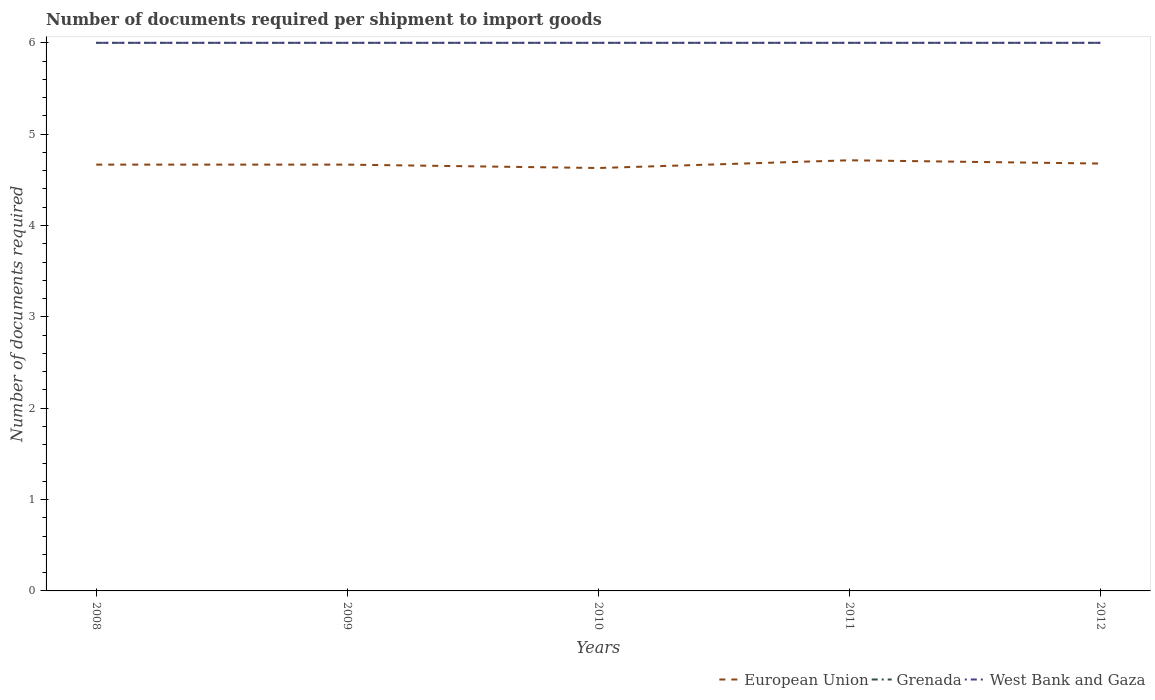Does the line corresponding to Grenada intersect with the line corresponding to European Union?
Offer a very short reply. No. Across all years, what is the maximum number of documents required per shipment to import goods in European Union?
Your answer should be very brief. 4.63. In which year was the number of documents required per shipment to import goods in West Bank and Gaza maximum?
Your response must be concise. 2008. What is the total number of documents required per shipment to import goods in European Union in the graph?
Provide a succinct answer. -0.01. What is the difference between the highest and the lowest number of documents required per shipment to import goods in European Union?
Offer a very short reply. 2. What is the difference between two consecutive major ticks on the Y-axis?
Make the answer very short. 1. Are the values on the major ticks of Y-axis written in scientific E-notation?
Make the answer very short. No. Where does the legend appear in the graph?
Provide a succinct answer. Bottom right. How many legend labels are there?
Your answer should be very brief. 3. How are the legend labels stacked?
Your answer should be compact. Horizontal. What is the title of the graph?
Your answer should be very brief. Number of documents required per shipment to import goods. What is the label or title of the Y-axis?
Keep it short and to the point. Number of documents required. What is the Number of documents required in European Union in 2008?
Your response must be concise. 4.67. What is the Number of documents required of European Union in 2009?
Your response must be concise. 4.67. What is the Number of documents required of West Bank and Gaza in 2009?
Keep it short and to the point. 6. What is the Number of documents required in European Union in 2010?
Offer a very short reply. 4.63. What is the Number of documents required of Grenada in 2010?
Keep it short and to the point. 6. What is the Number of documents required of European Union in 2011?
Your answer should be very brief. 4.71. What is the Number of documents required in Grenada in 2011?
Offer a very short reply. 6. What is the Number of documents required of West Bank and Gaza in 2011?
Your answer should be compact. 6. What is the Number of documents required in European Union in 2012?
Your response must be concise. 4.68. What is the Number of documents required in West Bank and Gaza in 2012?
Keep it short and to the point. 6. Across all years, what is the maximum Number of documents required in European Union?
Make the answer very short. 4.71. Across all years, what is the maximum Number of documents required of West Bank and Gaza?
Keep it short and to the point. 6. Across all years, what is the minimum Number of documents required in European Union?
Provide a succinct answer. 4.63. Across all years, what is the minimum Number of documents required in Grenada?
Your answer should be very brief. 6. What is the total Number of documents required of European Union in the graph?
Make the answer very short. 23.36. What is the total Number of documents required in Grenada in the graph?
Ensure brevity in your answer.  30. What is the difference between the Number of documents required of European Union in 2008 and that in 2009?
Make the answer very short. 0. What is the difference between the Number of documents required of European Union in 2008 and that in 2010?
Make the answer very short. 0.04. What is the difference between the Number of documents required in European Union in 2008 and that in 2011?
Keep it short and to the point. -0.05. What is the difference between the Number of documents required in European Union in 2008 and that in 2012?
Your answer should be compact. -0.01. What is the difference between the Number of documents required in European Union in 2009 and that in 2010?
Your answer should be very brief. 0.04. What is the difference between the Number of documents required in West Bank and Gaza in 2009 and that in 2010?
Provide a succinct answer. 0. What is the difference between the Number of documents required in European Union in 2009 and that in 2011?
Provide a succinct answer. -0.05. What is the difference between the Number of documents required in West Bank and Gaza in 2009 and that in 2011?
Give a very brief answer. 0. What is the difference between the Number of documents required in European Union in 2009 and that in 2012?
Offer a terse response. -0.01. What is the difference between the Number of documents required in Grenada in 2009 and that in 2012?
Your answer should be very brief. 0. What is the difference between the Number of documents required of West Bank and Gaza in 2009 and that in 2012?
Offer a very short reply. 0. What is the difference between the Number of documents required in European Union in 2010 and that in 2011?
Provide a short and direct response. -0.08. What is the difference between the Number of documents required of Grenada in 2010 and that in 2011?
Your response must be concise. 0. What is the difference between the Number of documents required in European Union in 2010 and that in 2012?
Give a very brief answer. -0.05. What is the difference between the Number of documents required in European Union in 2011 and that in 2012?
Your response must be concise. 0.04. What is the difference between the Number of documents required of Grenada in 2011 and that in 2012?
Give a very brief answer. 0. What is the difference between the Number of documents required of West Bank and Gaza in 2011 and that in 2012?
Give a very brief answer. 0. What is the difference between the Number of documents required of European Union in 2008 and the Number of documents required of Grenada in 2009?
Ensure brevity in your answer.  -1.33. What is the difference between the Number of documents required in European Union in 2008 and the Number of documents required in West Bank and Gaza in 2009?
Make the answer very short. -1.33. What is the difference between the Number of documents required of European Union in 2008 and the Number of documents required of Grenada in 2010?
Make the answer very short. -1.33. What is the difference between the Number of documents required of European Union in 2008 and the Number of documents required of West Bank and Gaza in 2010?
Provide a succinct answer. -1.33. What is the difference between the Number of documents required of European Union in 2008 and the Number of documents required of Grenada in 2011?
Offer a very short reply. -1.33. What is the difference between the Number of documents required in European Union in 2008 and the Number of documents required in West Bank and Gaza in 2011?
Keep it short and to the point. -1.33. What is the difference between the Number of documents required in Grenada in 2008 and the Number of documents required in West Bank and Gaza in 2011?
Give a very brief answer. 0. What is the difference between the Number of documents required in European Union in 2008 and the Number of documents required in Grenada in 2012?
Provide a short and direct response. -1.33. What is the difference between the Number of documents required in European Union in 2008 and the Number of documents required in West Bank and Gaza in 2012?
Offer a terse response. -1.33. What is the difference between the Number of documents required in Grenada in 2008 and the Number of documents required in West Bank and Gaza in 2012?
Make the answer very short. 0. What is the difference between the Number of documents required of European Union in 2009 and the Number of documents required of Grenada in 2010?
Provide a short and direct response. -1.33. What is the difference between the Number of documents required of European Union in 2009 and the Number of documents required of West Bank and Gaza in 2010?
Your answer should be compact. -1.33. What is the difference between the Number of documents required of European Union in 2009 and the Number of documents required of Grenada in 2011?
Provide a succinct answer. -1.33. What is the difference between the Number of documents required of European Union in 2009 and the Number of documents required of West Bank and Gaza in 2011?
Give a very brief answer. -1.33. What is the difference between the Number of documents required of European Union in 2009 and the Number of documents required of Grenada in 2012?
Give a very brief answer. -1.33. What is the difference between the Number of documents required of European Union in 2009 and the Number of documents required of West Bank and Gaza in 2012?
Make the answer very short. -1.33. What is the difference between the Number of documents required in Grenada in 2009 and the Number of documents required in West Bank and Gaza in 2012?
Offer a very short reply. 0. What is the difference between the Number of documents required in European Union in 2010 and the Number of documents required in Grenada in 2011?
Your answer should be compact. -1.37. What is the difference between the Number of documents required in European Union in 2010 and the Number of documents required in West Bank and Gaza in 2011?
Offer a very short reply. -1.37. What is the difference between the Number of documents required of European Union in 2010 and the Number of documents required of Grenada in 2012?
Provide a short and direct response. -1.37. What is the difference between the Number of documents required of European Union in 2010 and the Number of documents required of West Bank and Gaza in 2012?
Make the answer very short. -1.37. What is the difference between the Number of documents required in European Union in 2011 and the Number of documents required in Grenada in 2012?
Make the answer very short. -1.29. What is the difference between the Number of documents required in European Union in 2011 and the Number of documents required in West Bank and Gaza in 2012?
Your answer should be compact. -1.29. What is the difference between the Number of documents required in Grenada in 2011 and the Number of documents required in West Bank and Gaza in 2012?
Make the answer very short. 0. What is the average Number of documents required in European Union per year?
Keep it short and to the point. 4.67. What is the average Number of documents required in Grenada per year?
Give a very brief answer. 6. What is the average Number of documents required of West Bank and Gaza per year?
Offer a very short reply. 6. In the year 2008, what is the difference between the Number of documents required of European Union and Number of documents required of Grenada?
Offer a very short reply. -1.33. In the year 2008, what is the difference between the Number of documents required of European Union and Number of documents required of West Bank and Gaza?
Your answer should be very brief. -1.33. In the year 2009, what is the difference between the Number of documents required in European Union and Number of documents required in Grenada?
Make the answer very short. -1.33. In the year 2009, what is the difference between the Number of documents required in European Union and Number of documents required in West Bank and Gaza?
Your answer should be compact. -1.33. In the year 2009, what is the difference between the Number of documents required of Grenada and Number of documents required of West Bank and Gaza?
Your answer should be compact. 0. In the year 2010, what is the difference between the Number of documents required of European Union and Number of documents required of Grenada?
Make the answer very short. -1.37. In the year 2010, what is the difference between the Number of documents required of European Union and Number of documents required of West Bank and Gaza?
Ensure brevity in your answer.  -1.37. In the year 2011, what is the difference between the Number of documents required in European Union and Number of documents required in Grenada?
Your answer should be compact. -1.29. In the year 2011, what is the difference between the Number of documents required of European Union and Number of documents required of West Bank and Gaza?
Provide a succinct answer. -1.29. In the year 2011, what is the difference between the Number of documents required in Grenada and Number of documents required in West Bank and Gaza?
Your answer should be compact. 0. In the year 2012, what is the difference between the Number of documents required of European Union and Number of documents required of Grenada?
Ensure brevity in your answer.  -1.32. In the year 2012, what is the difference between the Number of documents required in European Union and Number of documents required in West Bank and Gaza?
Give a very brief answer. -1.32. What is the ratio of the Number of documents required of Grenada in 2008 to that in 2009?
Offer a very short reply. 1. What is the ratio of the Number of documents required in West Bank and Gaza in 2008 to that in 2010?
Make the answer very short. 1. What is the ratio of the Number of documents required in European Union in 2008 to that in 2011?
Your response must be concise. 0.99. What is the ratio of the Number of documents required in Grenada in 2008 to that in 2011?
Provide a succinct answer. 1. What is the ratio of the Number of documents required of West Bank and Gaza in 2008 to that in 2011?
Offer a terse response. 1. What is the ratio of the Number of documents required in Grenada in 2008 to that in 2012?
Offer a very short reply. 1. What is the ratio of the Number of documents required in European Union in 2009 to that in 2010?
Provide a short and direct response. 1.01. What is the ratio of the Number of documents required in Grenada in 2009 to that in 2011?
Give a very brief answer. 1. What is the ratio of the Number of documents required in Grenada in 2010 to that in 2011?
Provide a succinct answer. 1. What is the ratio of the Number of documents required in Grenada in 2010 to that in 2012?
Your response must be concise. 1. What is the ratio of the Number of documents required in European Union in 2011 to that in 2012?
Provide a short and direct response. 1.01. What is the ratio of the Number of documents required in West Bank and Gaza in 2011 to that in 2012?
Offer a very short reply. 1. What is the difference between the highest and the second highest Number of documents required of European Union?
Keep it short and to the point. 0.04. What is the difference between the highest and the second highest Number of documents required in Grenada?
Keep it short and to the point. 0. What is the difference between the highest and the lowest Number of documents required in European Union?
Ensure brevity in your answer.  0.08. What is the difference between the highest and the lowest Number of documents required of Grenada?
Give a very brief answer. 0. What is the difference between the highest and the lowest Number of documents required in West Bank and Gaza?
Ensure brevity in your answer.  0. 